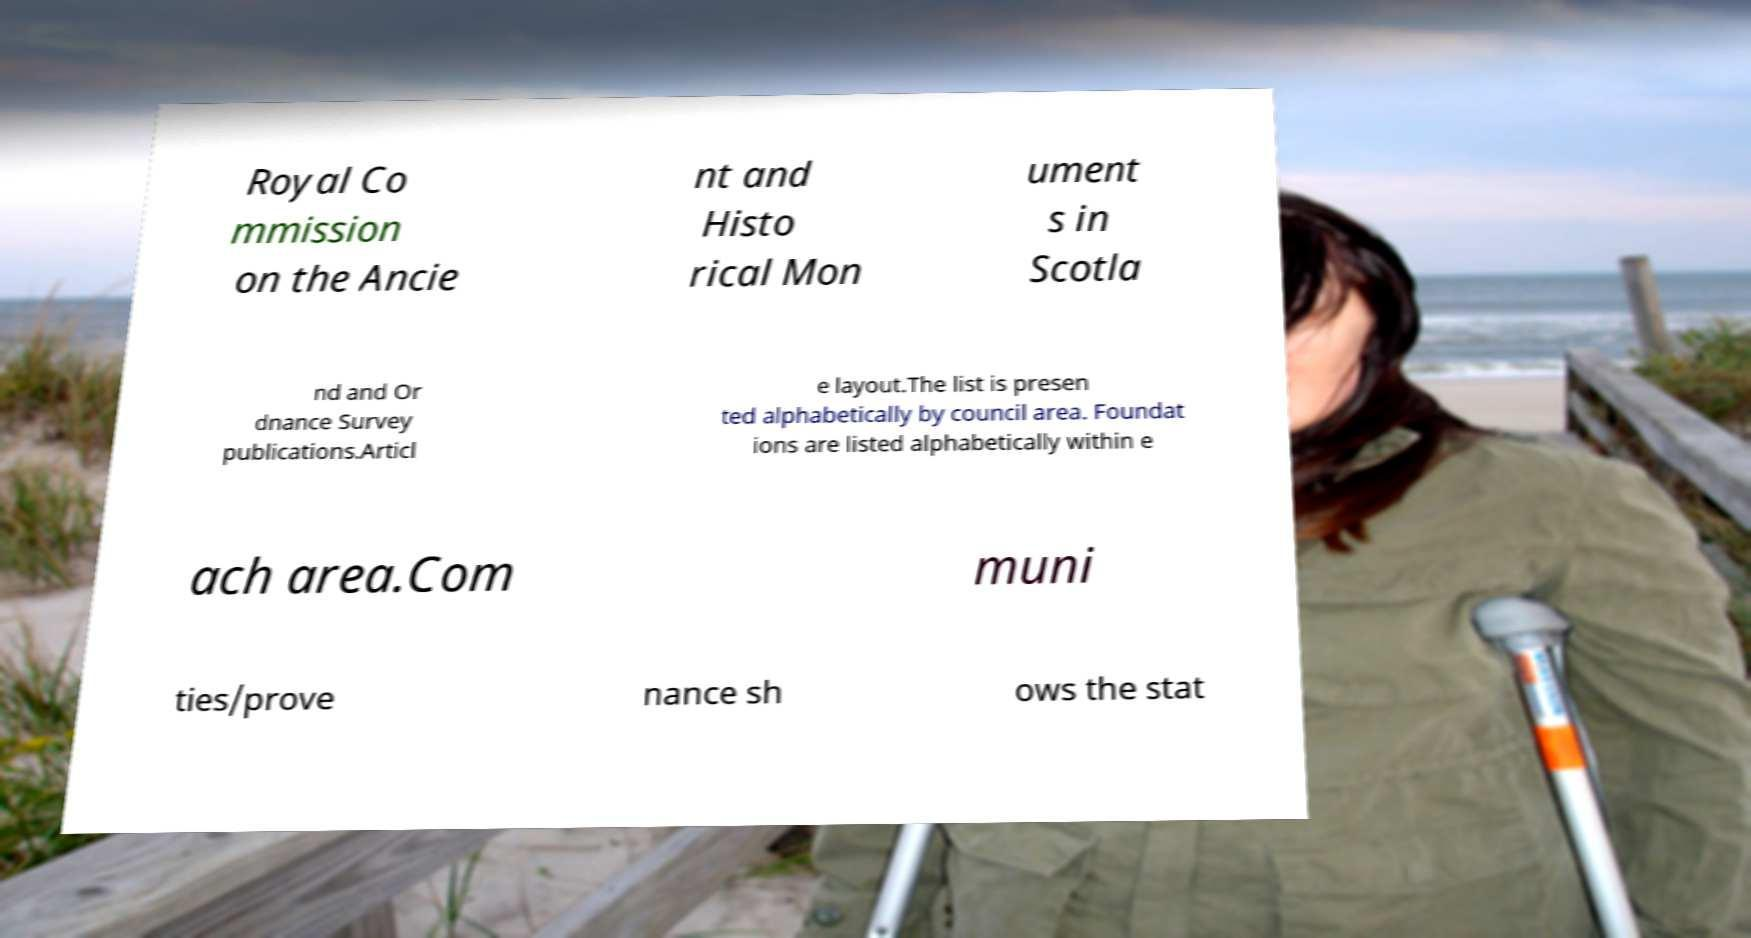Could you extract and type out the text from this image? Royal Co mmission on the Ancie nt and Histo rical Mon ument s in Scotla nd and Or dnance Survey publications.Articl e layout.The list is presen ted alphabetically by council area. Foundat ions are listed alphabetically within e ach area.Com muni ties/prove nance sh ows the stat 